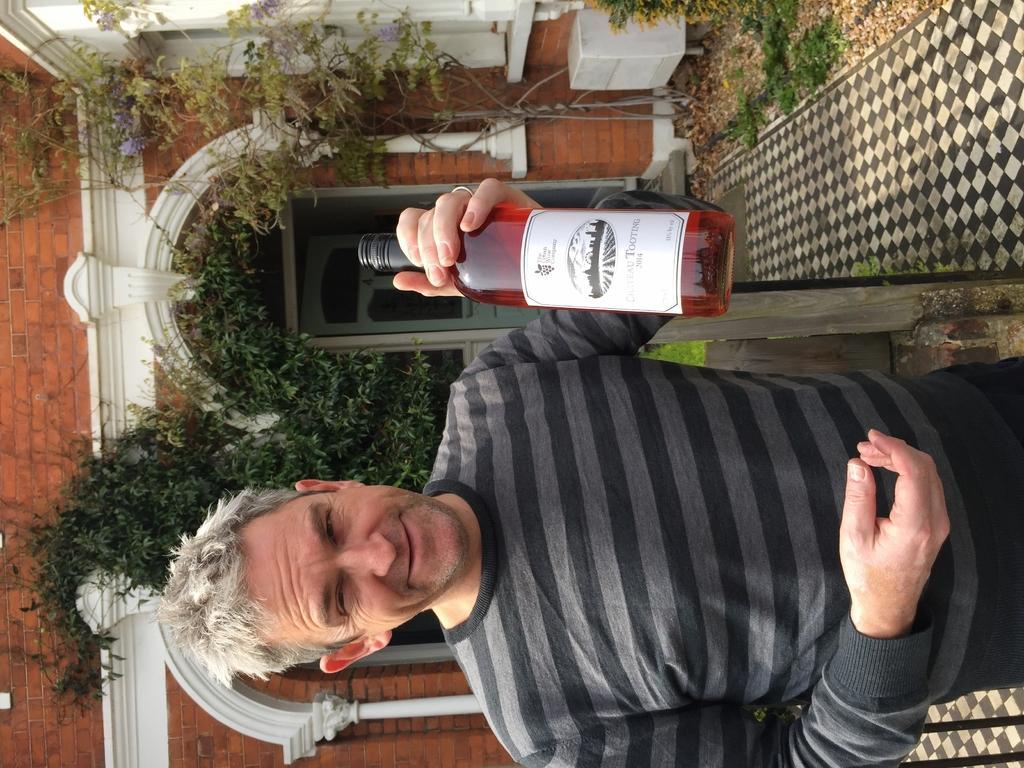In one or two sentences, can you explain what this image depicts? In this picture we can see a person,he is holding a bottle and in the background we can see a building,trees. 